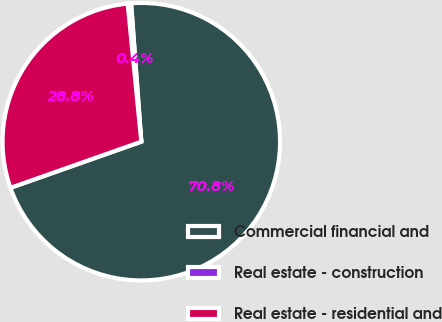Convert chart. <chart><loc_0><loc_0><loc_500><loc_500><pie_chart><fcel>Commercial financial and<fcel>Real estate - construction<fcel>Real estate - residential and<nl><fcel>70.77%<fcel>0.4%<fcel>28.83%<nl></chart> 